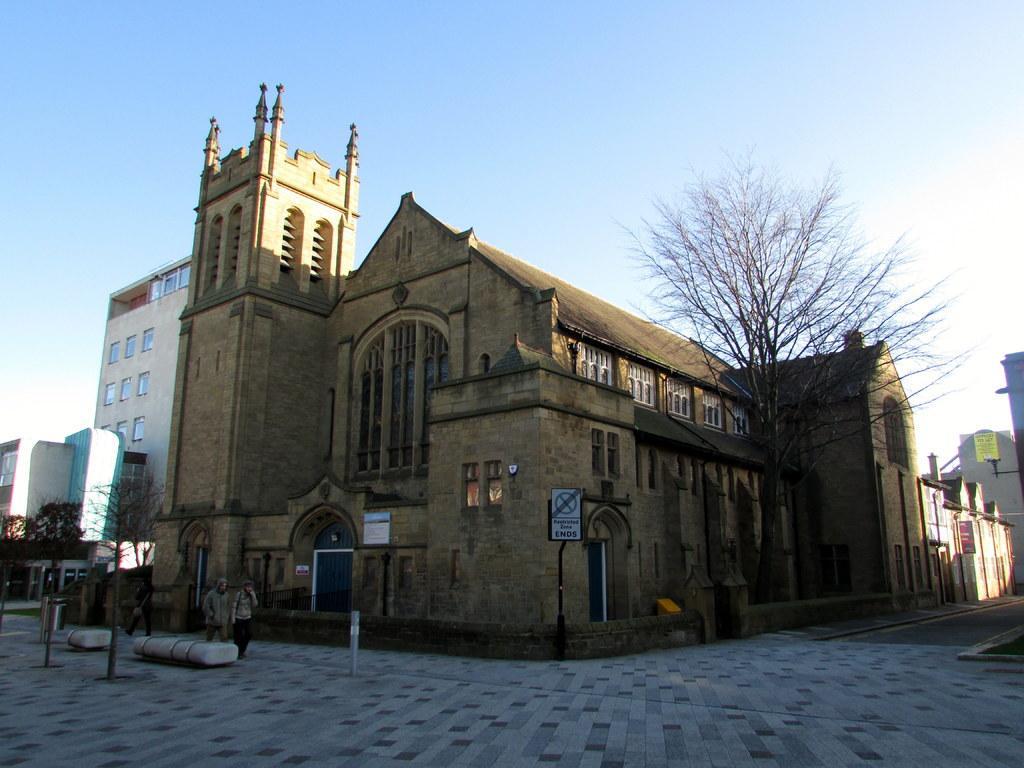How would you summarize this image in a sentence or two? In the middle there is a big house, on the left side 2 persons are walking on the footpath. On the right side there is a tree. At the top it is the sky. 